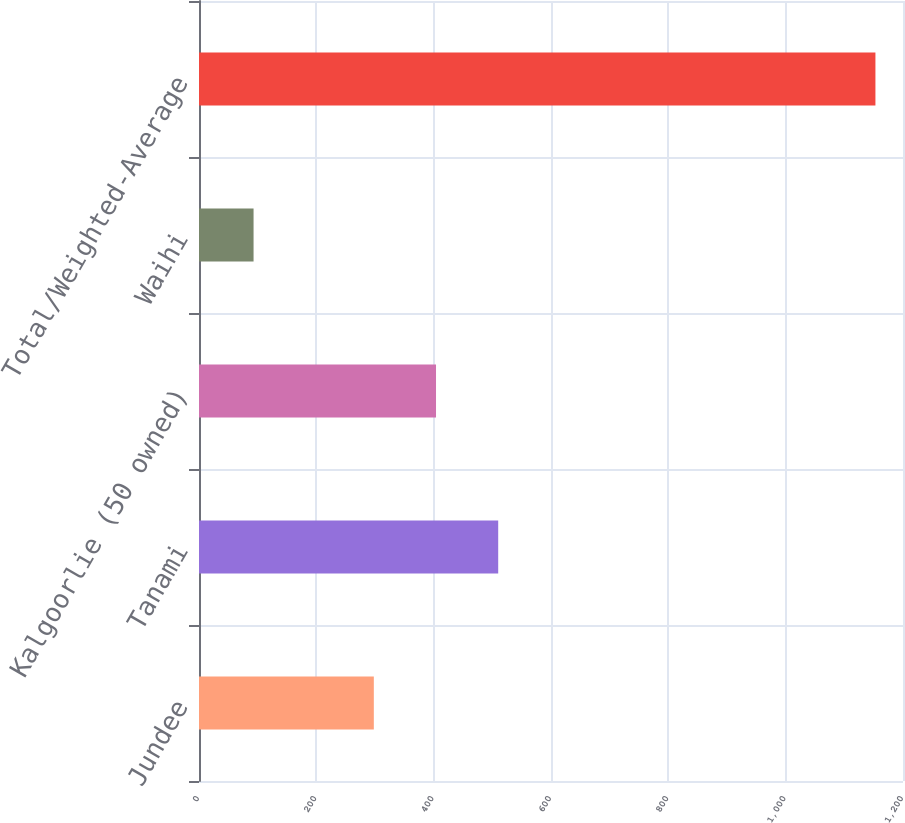Convert chart to OTSL. <chart><loc_0><loc_0><loc_500><loc_500><bar_chart><fcel>Jundee<fcel>Tanami<fcel>Kalgoorlie (50 owned)<fcel>Waihi<fcel>Total/Weighted-Average<nl><fcel>298<fcel>510<fcel>404<fcel>93<fcel>1153<nl></chart> 